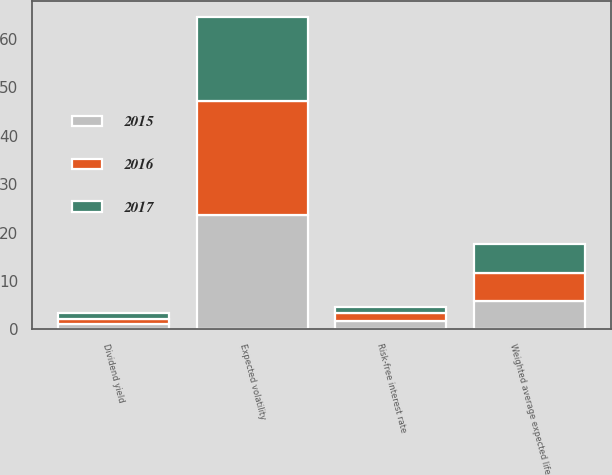Convert chart. <chart><loc_0><loc_0><loc_500><loc_500><stacked_bar_chart><ecel><fcel>Dividend yield<fcel>Expected volatility<fcel>Weighted average expected life<fcel>Risk-free interest rate<nl><fcel>2017<fcel>1.1<fcel>17.4<fcel>6<fcel>1.3<nl><fcel>2016<fcel>1<fcel>23.6<fcel>5.8<fcel>1.7<nl><fcel>2015<fcel>1.2<fcel>23.6<fcel>5.8<fcel>1.7<nl></chart> 